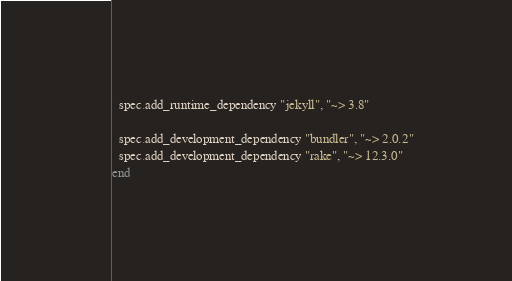<code> <loc_0><loc_0><loc_500><loc_500><_Ruby_>
  spec.add_runtime_dependency "jekyll", "~> 3.8"

  spec.add_development_dependency "bundler", "~> 2.0.2"
  spec.add_development_dependency "rake", "~> 12.3.0"
end
</code> 